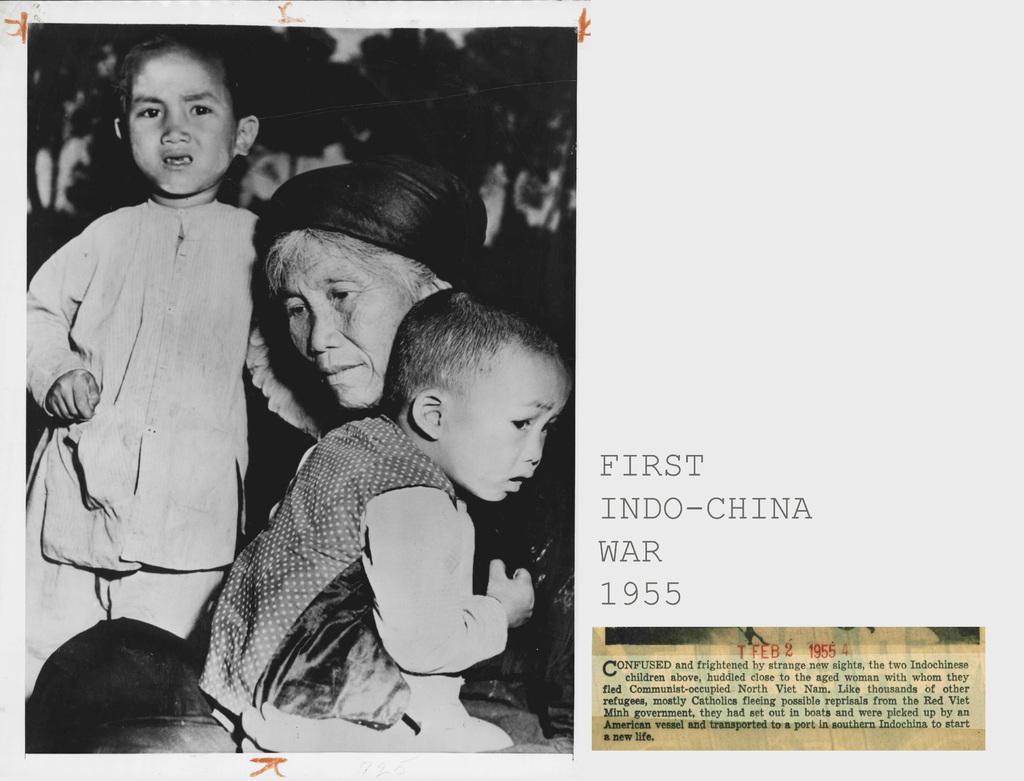Can you describe this image briefly? In this picture we can see a poster and on this poster we can see a photo, some text and on this photo we can see three people and trees. 